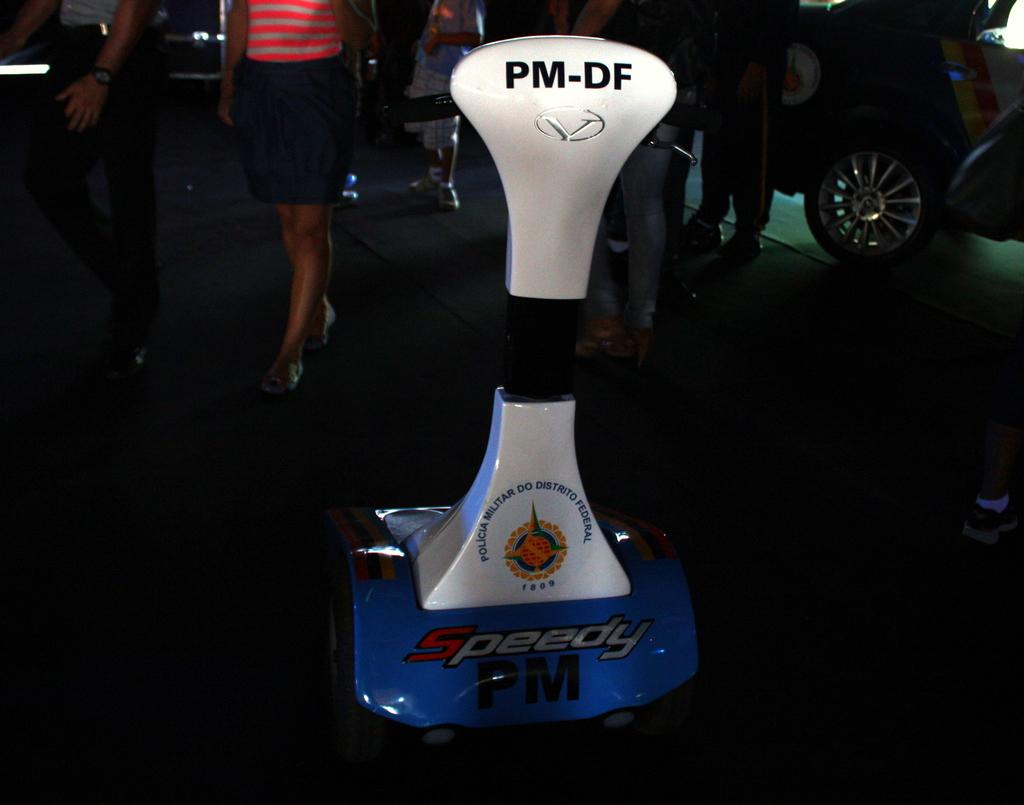What is the colored object on the floor in the image? There is a white, black, and blue colored object on the floor. Can you describe the people in the background of the image? There are persons standing in the background of the image. What is the car placed on in the background of the image? There is a car on a green colored carpet in the background of the image. What type of patch is sewn onto the seat in the image? There is no seat or patch present in the image. 